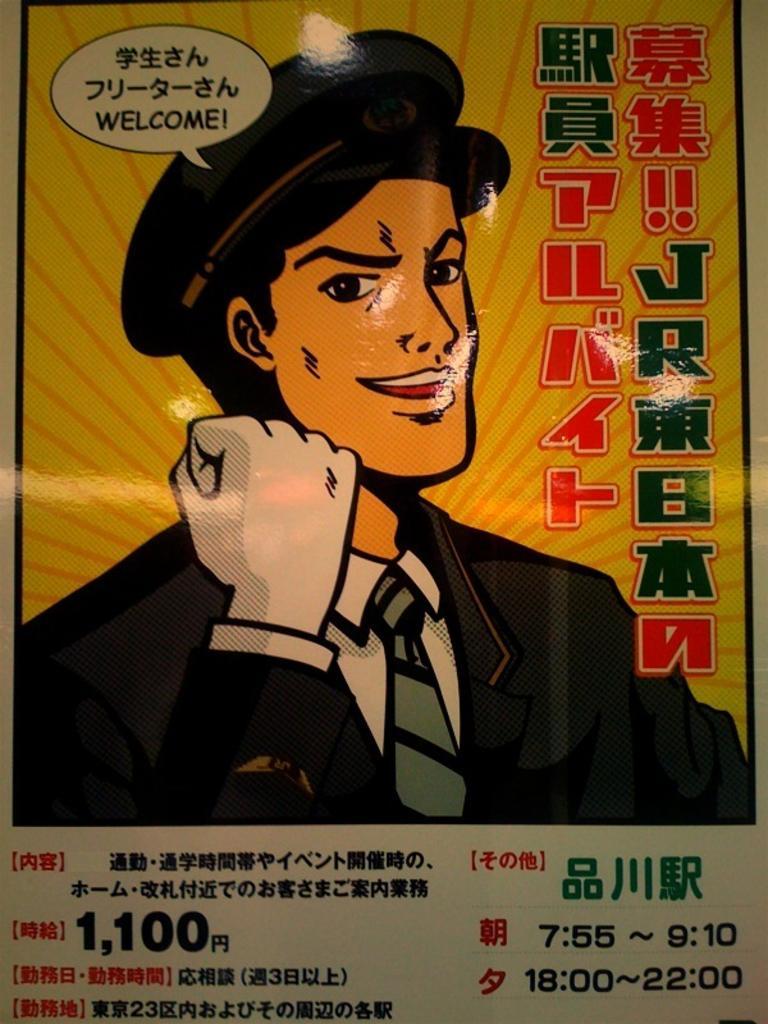Could you give a brief overview of what you see in this image? As we can see in the image there is a poster. On poster there is a man wearing black color jacket. 